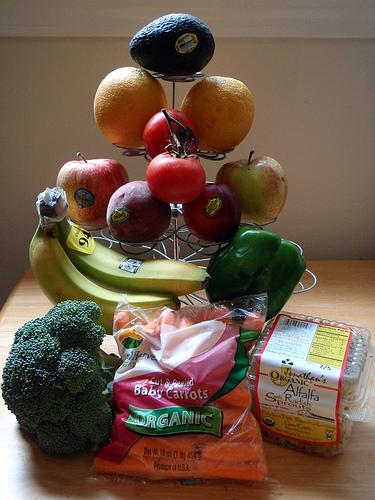What kind of carrots are in the bag?
Concise answer only. Baby. Is there cabbage in the picture?
Short answer required. No. Is there any meat visible?
Short answer required. No. Is this a sweet food?
Give a very brief answer. No. What vegetable is on top of the rack?
Quick response, please. Avocado. 